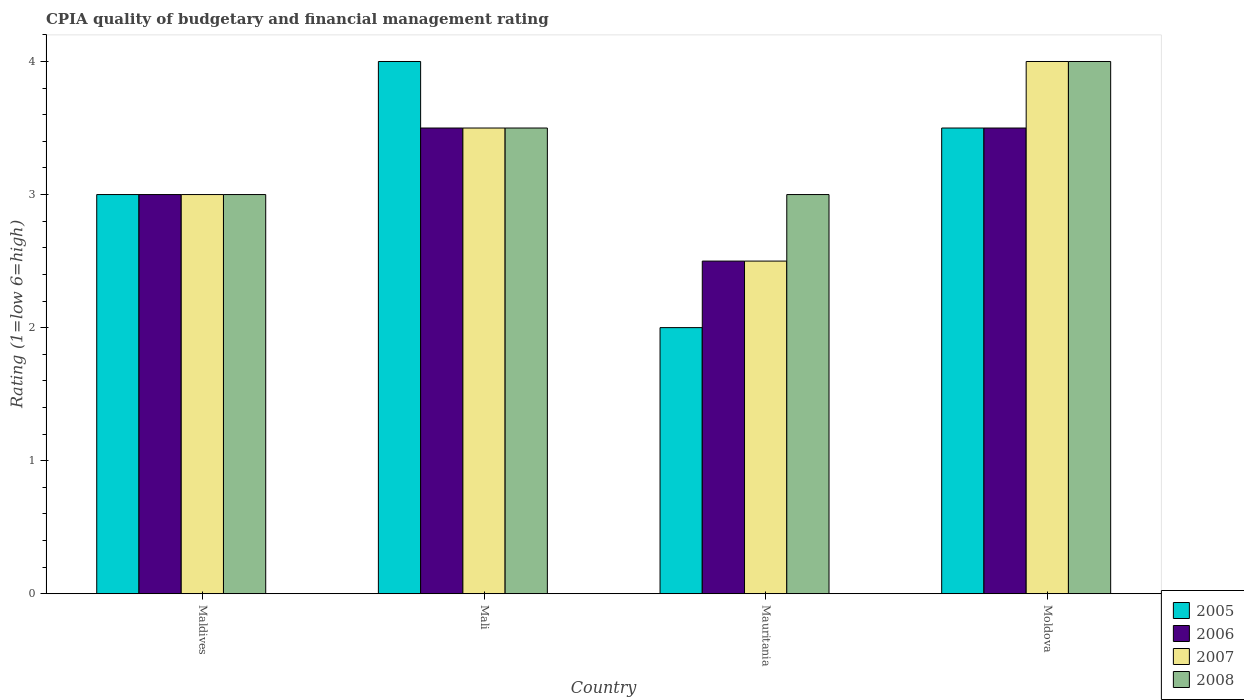Are the number of bars per tick equal to the number of legend labels?
Make the answer very short. Yes. Are the number of bars on each tick of the X-axis equal?
Offer a terse response. Yes. What is the label of the 3rd group of bars from the left?
Keep it short and to the point. Mauritania. In how many cases, is the number of bars for a given country not equal to the number of legend labels?
Offer a very short reply. 0. What is the CPIA rating in 2006 in Mauritania?
Your answer should be compact. 2.5. Across all countries, what is the maximum CPIA rating in 2005?
Ensure brevity in your answer.  4. Across all countries, what is the minimum CPIA rating in 2005?
Offer a terse response. 2. In which country was the CPIA rating in 2005 maximum?
Keep it short and to the point. Mali. In which country was the CPIA rating in 2005 minimum?
Provide a short and direct response. Mauritania. What is the average CPIA rating in 2008 per country?
Your response must be concise. 3.38. What is the difference between the highest and the second highest CPIA rating in 2006?
Keep it short and to the point. -0.5. What is the difference between the highest and the lowest CPIA rating in 2007?
Your answer should be very brief. 1.5. In how many countries, is the CPIA rating in 2008 greater than the average CPIA rating in 2008 taken over all countries?
Offer a terse response. 2. Is the sum of the CPIA rating in 2006 in Maldives and Mauritania greater than the maximum CPIA rating in 2008 across all countries?
Offer a terse response. Yes. How many countries are there in the graph?
Give a very brief answer. 4. What is the difference between two consecutive major ticks on the Y-axis?
Your answer should be compact. 1. Does the graph contain any zero values?
Your response must be concise. No. How many legend labels are there?
Your answer should be very brief. 4. What is the title of the graph?
Offer a very short reply. CPIA quality of budgetary and financial management rating. Does "1982" appear as one of the legend labels in the graph?
Your answer should be compact. No. What is the label or title of the Y-axis?
Your response must be concise. Rating (1=low 6=high). What is the Rating (1=low 6=high) in 2006 in Maldives?
Offer a terse response. 3. What is the Rating (1=low 6=high) of 2006 in Mali?
Provide a short and direct response. 3.5. What is the Rating (1=low 6=high) of 2008 in Mali?
Provide a short and direct response. 3.5. What is the Rating (1=low 6=high) in 2008 in Mauritania?
Provide a succinct answer. 3. What is the Rating (1=low 6=high) of 2006 in Moldova?
Your response must be concise. 3.5. What is the Rating (1=low 6=high) in 2007 in Moldova?
Ensure brevity in your answer.  4. Across all countries, what is the maximum Rating (1=low 6=high) in 2005?
Keep it short and to the point. 4. Across all countries, what is the maximum Rating (1=low 6=high) of 2007?
Keep it short and to the point. 4. Across all countries, what is the maximum Rating (1=low 6=high) of 2008?
Offer a terse response. 4. Across all countries, what is the minimum Rating (1=low 6=high) of 2008?
Keep it short and to the point. 3. What is the total Rating (1=low 6=high) in 2005 in the graph?
Offer a terse response. 12.5. What is the difference between the Rating (1=low 6=high) in 2006 in Maldives and that in Mali?
Make the answer very short. -0.5. What is the difference between the Rating (1=low 6=high) in 2007 in Maldives and that in Mali?
Give a very brief answer. -0.5. What is the difference between the Rating (1=low 6=high) in 2005 in Maldives and that in Mauritania?
Offer a terse response. 1. What is the difference between the Rating (1=low 6=high) of 2005 in Maldives and that in Moldova?
Offer a terse response. -0.5. What is the difference between the Rating (1=low 6=high) of 2006 in Maldives and that in Moldova?
Give a very brief answer. -0.5. What is the difference between the Rating (1=low 6=high) in 2007 in Maldives and that in Moldova?
Make the answer very short. -1. What is the difference between the Rating (1=low 6=high) of 2008 in Maldives and that in Moldova?
Your answer should be very brief. -1. What is the difference between the Rating (1=low 6=high) of 2005 in Mali and that in Mauritania?
Your response must be concise. 2. What is the difference between the Rating (1=low 6=high) in 2006 in Mali and that in Mauritania?
Your response must be concise. 1. What is the difference between the Rating (1=low 6=high) of 2008 in Mali and that in Mauritania?
Your answer should be compact. 0.5. What is the difference between the Rating (1=low 6=high) of 2007 in Mali and that in Moldova?
Provide a succinct answer. -0.5. What is the difference between the Rating (1=low 6=high) in 2005 in Mauritania and that in Moldova?
Keep it short and to the point. -1.5. What is the difference between the Rating (1=low 6=high) of 2006 in Mauritania and that in Moldova?
Offer a very short reply. -1. What is the difference between the Rating (1=low 6=high) in 2007 in Mauritania and that in Moldova?
Ensure brevity in your answer.  -1.5. What is the difference between the Rating (1=low 6=high) in 2008 in Mauritania and that in Moldova?
Your response must be concise. -1. What is the difference between the Rating (1=low 6=high) in 2005 in Maldives and the Rating (1=low 6=high) in 2006 in Mali?
Give a very brief answer. -0.5. What is the difference between the Rating (1=low 6=high) in 2005 in Maldives and the Rating (1=low 6=high) in 2007 in Mali?
Your answer should be compact. -0.5. What is the difference between the Rating (1=low 6=high) in 2005 in Maldives and the Rating (1=low 6=high) in 2008 in Mali?
Offer a terse response. -0.5. What is the difference between the Rating (1=low 6=high) in 2005 in Maldives and the Rating (1=low 6=high) in 2006 in Mauritania?
Offer a terse response. 0.5. What is the difference between the Rating (1=low 6=high) of 2006 in Maldives and the Rating (1=low 6=high) of 2007 in Mauritania?
Make the answer very short. 0.5. What is the difference between the Rating (1=low 6=high) in 2006 in Maldives and the Rating (1=low 6=high) in 2008 in Mauritania?
Make the answer very short. 0. What is the difference between the Rating (1=low 6=high) in 2007 in Maldives and the Rating (1=low 6=high) in 2008 in Mauritania?
Offer a terse response. 0. What is the difference between the Rating (1=low 6=high) in 2005 in Maldives and the Rating (1=low 6=high) in 2006 in Moldova?
Your response must be concise. -0.5. What is the difference between the Rating (1=low 6=high) in 2005 in Maldives and the Rating (1=low 6=high) in 2007 in Moldova?
Make the answer very short. -1. What is the difference between the Rating (1=low 6=high) in 2005 in Maldives and the Rating (1=low 6=high) in 2008 in Moldova?
Make the answer very short. -1. What is the difference between the Rating (1=low 6=high) in 2006 in Maldives and the Rating (1=low 6=high) in 2007 in Moldova?
Make the answer very short. -1. What is the difference between the Rating (1=low 6=high) of 2005 in Mali and the Rating (1=low 6=high) of 2006 in Mauritania?
Provide a short and direct response. 1.5. What is the difference between the Rating (1=low 6=high) of 2005 in Mali and the Rating (1=low 6=high) of 2007 in Mauritania?
Make the answer very short. 1.5. What is the difference between the Rating (1=low 6=high) of 2006 in Mali and the Rating (1=low 6=high) of 2008 in Mauritania?
Keep it short and to the point. 0.5. What is the difference between the Rating (1=low 6=high) in 2005 in Mali and the Rating (1=low 6=high) in 2007 in Moldova?
Your response must be concise. 0. What is the difference between the Rating (1=low 6=high) in 2005 in Mali and the Rating (1=low 6=high) in 2008 in Moldova?
Your answer should be compact. 0. What is the difference between the Rating (1=low 6=high) in 2006 in Mali and the Rating (1=low 6=high) in 2008 in Moldova?
Your answer should be very brief. -0.5. What is the difference between the Rating (1=low 6=high) in 2005 in Mauritania and the Rating (1=low 6=high) in 2006 in Moldova?
Make the answer very short. -1.5. What is the difference between the Rating (1=low 6=high) in 2005 in Mauritania and the Rating (1=low 6=high) in 2008 in Moldova?
Keep it short and to the point. -2. What is the difference between the Rating (1=low 6=high) in 2006 in Mauritania and the Rating (1=low 6=high) in 2007 in Moldova?
Your response must be concise. -1.5. What is the difference between the Rating (1=low 6=high) in 2006 in Mauritania and the Rating (1=low 6=high) in 2008 in Moldova?
Provide a succinct answer. -1.5. What is the difference between the Rating (1=low 6=high) of 2007 in Mauritania and the Rating (1=low 6=high) of 2008 in Moldova?
Your response must be concise. -1.5. What is the average Rating (1=low 6=high) of 2005 per country?
Your answer should be very brief. 3.12. What is the average Rating (1=low 6=high) in 2006 per country?
Give a very brief answer. 3.12. What is the average Rating (1=low 6=high) of 2007 per country?
Keep it short and to the point. 3.25. What is the average Rating (1=low 6=high) in 2008 per country?
Ensure brevity in your answer.  3.38. What is the difference between the Rating (1=low 6=high) in 2005 and Rating (1=low 6=high) in 2006 in Maldives?
Provide a succinct answer. 0. What is the difference between the Rating (1=low 6=high) of 2006 and Rating (1=low 6=high) of 2008 in Mali?
Make the answer very short. 0. What is the difference between the Rating (1=low 6=high) in 2005 and Rating (1=low 6=high) in 2008 in Mauritania?
Provide a short and direct response. -1. What is the difference between the Rating (1=low 6=high) of 2006 and Rating (1=low 6=high) of 2007 in Mauritania?
Keep it short and to the point. 0. What is the difference between the Rating (1=low 6=high) in 2007 and Rating (1=low 6=high) in 2008 in Mauritania?
Provide a short and direct response. -0.5. What is the difference between the Rating (1=low 6=high) in 2005 and Rating (1=low 6=high) in 2006 in Moldova?
Provide a succinct answer. 0. What is the difference between the Rating (1=low 6=high) of 2005 and Rating (1=low 6=high) of 2007 in Moldova?
Your answer should be compact. -0.5. What is the difference between the Rating (1=low 6=high) of 2005 and Rating (1=low 6=high) of 2008 in Moldova?
Ensure brevity in your answer.  -0.5. What is the difference between the Rating (1=low 6=high) of 2006 and Rating (1=low 6=high) of 2007 in Moldova?
Your answer should be very brief. -0.5. What is the ratio of the Rating (1=low 6=high) in 2006 in Maldives to that in Mali?
Give a very brief answer. 0.86. What is the ratio of the Rating (1=low 6=high) of 2007 in Maldives to that in Mali?
Your answer should be compact. 0.86. What is the ratio of the Rating (1=low 6=high) in 2005 in Maldives to that in Mauritania?
Ensure brevity in your answer.  1.5. What is the ratio of the Rating (1=low 6=high) of 2006 in Maldives to that in Mauritania?
Your answer should be very brief. 1.2. What is the ratio of the Rating (1=low 6=high) of 2007 in Maldives to that in Mauritania?
Your response must be concise. 1.2. What is the ratio of the Rating (1=low 6=high) in 2008 in Maldives to that in Mauritania?
Provide a short and direct response. 1. What is the ratio of the Rating (1=low 6=high) of 2006 in Maldives to that in Moldova?
Your response must be concise. 0.86. What is the ratio of the Rating (1=low 6=high) in 2007 in Maldives to that in Moldova?
Provide a short and direct response. 0.75. What is the ratio of the Rating (1=low 6=high) in 2008 in Maldives to that in Moldova?
Give a very brief answer. 0.75. What is the ratio of the Rating (1=low 6=high) of 2005 in Mali to that in Mauritania?
Your response must be concise. 2. What is the ratio of the Rating (1=low 6=high) of 2007 in Mali to that in Mauritania?
Ensure brevity in your answer.  1.4. What is the ratio of the Rating (1=low 6=high) of 2007 in Mali to that in Moldova?
Your answer should be compact. 0.88. What is the ratio of the Rating (1=low 6=high) in 2008 in Mali to that in Moldova?
Keep it short and to the point. 0.88. What is the ratio of the Rating (1=low 6=high) of 2005 in Mauritania to that in Moldova?
Your answer should be compact. 0.57. What is the difference between the highest and the second highest Rating (1=low 6=high) in 2005?
Give a very brief answer. 0.5. What is the difference between the highest and the second highest Rating (1=low 6=high) of 2007?
Keep it short and to the point. 0.5. 